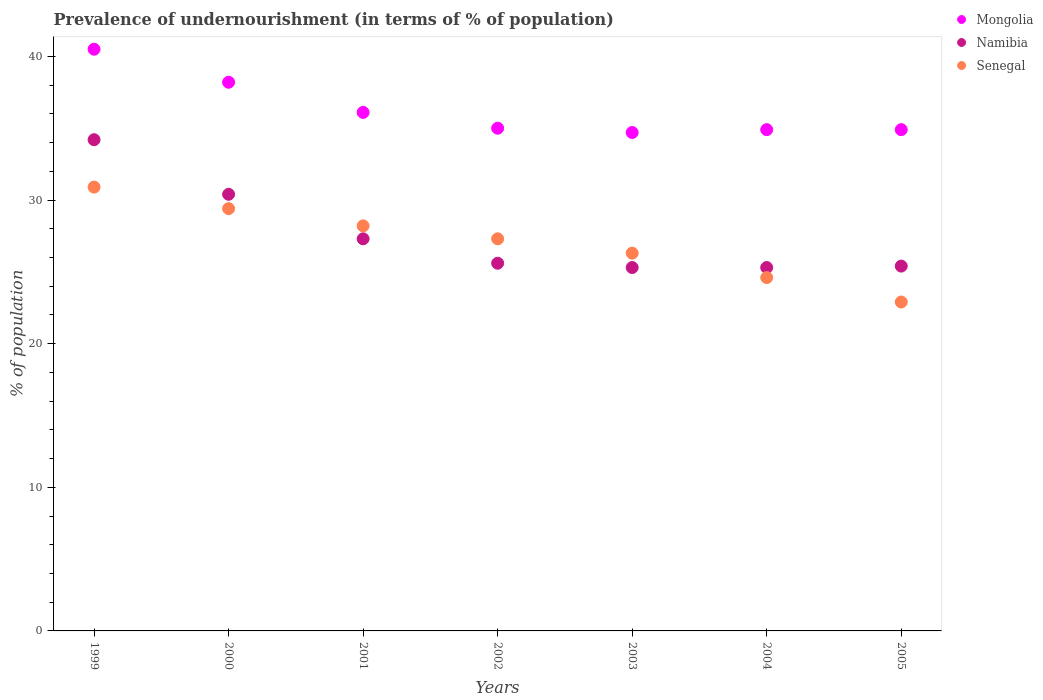How many different coloured dotlines are there?
Ensure brevity in your answer.  3. Is the number of dotlines equal to the number of legend labels?
Give a very brief answer. Yes. What is the percentage of undernourished population in Mongolia in 2004?
Your answer should be very brief. 34.9. Across all years, what is the maximum percentage of undernourished population in Senegal?
Your response must be concise. 30.9. Across all years, what is the minimum percentage of undernourished population in Senegal?
Make the answer very short. 22.9. In which year was the percentage of undernourished population in Senegal maximum?
Your response must be concise. 1999. What is the total percentage of undernourished population in Namibia in the graph?
Provide a succinct answer. 193.5. What is the difference between the percentage of undernourished population in Mongolia in 1999 and that in 2000?
Provide a short and direct response. 2.3. What is the difference between the percentage of undernourished population in Senegal in 2004 and the percentage of undernourished population in Mongolia in 2003?
Offer a terse response. -10.1. What is the average percentage of undernourished population in Senegal per year?
Offer a very short reply. 27.09. What is the ratio of the percentage of undernourished population in Senegal in 2004 to that in 2005?
Your answer should be very brief. 1.07. Is the percentage of undernourished population in Senegal in 2003 less than that in 2005?
Offer a very short reply. No. Is the difference between the percentage of undernourished population in Namibia in 2000 and 2001 greater than the difference between the percentage of undernourished population in Senegal in 2000 and 2001?
Your response must be concise. Yes. What is the difference between the highest and the second highest percentage of undernourished population in Senegal?
Your response must be concise. 1.5. What is the difference between the highest and the lowest percentage of undernourished population in Namibia?
Offer a very short reply. 8.9. In how many years, is the percentage of undernourished population in Namibia greater than the average percentage of undernourished population in Namibia taken over all years?
Your answer should be compact. 2. Is it the case that in every year, the sum of the percentage of undernourished population in Senegal and percentage of undernourished population in Namibia  is greater than the percentage of undernourished population in Mongolia?
Keep it short and to the point. Yes. Is the percentage of undernourished population in Namibia strictly less than the percentage of undernourished population in Mongolia over the years?
Your response must be concise. Yes. How many dotlines are there?
Ensure brevity in your answer.  3. How many years are there in the graph?
Provide a succinct answer. 7. What is the difference between two consecutive major ticks on the Y-axis?
Offer a terse response. 10. Does the graph contain any zero values?
Make the answer very short. No. Where does the legend appear in the graph?
Your response must be concise. Top right. How many legend labels are there?
Provide a succinct answer. 3. What is the title of the graph?
Offer a terse response. Prevalence of undernourishment (in terms of % of population). What is the label or title of the Y-axis?
Provide a succinct answer. % of population. What is the % of population of Mongolia in 1999?
Offer a very short reply. 40.5. What is the % of population in Namibia in 1999?
Provide a short and direct response. 34.2. What is the % of population in Senegal in 1999?
Your response must be concise. 30.9. What is the % of population of Mongolia in 2000?
Ensure brevity in your answer.  38.2. What is the % of population in Namibia in 2000?
Ensure brevity in your answer.  30.4. What is the % of population in Senegal in 2000?
Offer a very short reply. 29.4. What is the % of population in Mongolia in 2001?
Give a very brief answer. 36.1. What is the % of population in Namibia in 2001?
Provide a succinct answer. 27.3. What is the % of population in Senegal in 2001?
Offer a very short reply. 28.2. What is the % of population in Mongolia in 2002?
Give a very brief answer. 35. What is the % of population of Namibia in 2002?
Offer a terse response. 25.6. What is the % of population in Senegal in 2002?
Offer a terse response. 27.3. What is the % of population of Mongolia in 2003?
Make the answer very short. 34.7. What is the % of population of Namibia in 2003?
Your answer should be compact. 25.3. What is the % of population of Senegal in 2003?
Make the answer very short. 26.3. What is the % of population in Mongolia in 2004?
Ensure brevity in your answer.  34.9. What is the % of population of Namibia in 2004?
Offer a very short reply. 25.3. What is the % of population in Senegal in 2004?
Offer a very short reply. 24.6. What is the % of population in Mongolia in 2005?
Provide a succinct answer. 34.9. What is the % of population in Namibia in 2005?
Offer a very short reply. 25.4. What is the % of population of Senegal in 2005?
Your answer should be compact. 22.9. Across all years, what is the maximum % of population of Mongolia?
Provide a short and direct response. 40.5. Across all years, what is the maximum % of population of Namibia?
Keep it short and to the point. 34.2. Across all years, what is the maximum % of population of Senegal?
Make the answer very short. 30.9. Across all years, what is the minimum % of population of Mongolia?
Provide a short and direct response. 34.7. Across all years, what is the minimum % of population of Namibia?
Offer a terse response. 25.3. Across all years, what is the minimum % of population in Senegal?
Provide a succinct answer. 22.9. What is the total % of population in Mongolia in the graph?
Provide a short and direct response. 254.3. What is the total % of population in Namibia in the graph?
Offer a very short reply. 193.5. What is the total % of population of Senegal in the graph?
Your answer should be compact. 189.6. What is the difference between the % of population in Mongolia in 1999 and that in 2000?
Provide a succinct answer. 2.3. What is the difference between the % of population of Senegal in 1999 and that in 2000?
Ensure brevity in your answer.  1.5. What is the difference between the % of population in Mongolia in 1999 and that in 2001?
Keep it short and to the point. 4.4. What is the difference between the % of population of Namibia in 1999 and that in 2001?
Your answer should be compact. 6.9. What is the difference between the % of population of Mongolia in 1999 and that in 2002?
Keep it short and to the point. 5.5. What is the difference between the % of population in Senegal in 1999 and that in 2002?
Keep it short and to the point. 3.6. What is the difference between the % of population of Namibia in 1999 and that in 2003?
Your response must be concise. 8.9. What is the difference between the % of population of Senegal in 1999 and that in 2003?
Make the answer very short. 4.6. What is the difference between the % of population of Namibia in 1999 and that in 2004?
Ensure brevity in your answer.  8.9. What is the difference between the % of population in Senegal in 1999 and that in 2004?
Keep it short and to the point. 6.3. What is the difference between the % of population in Mongolia in 1999 and that in 2005?
Make the answer very short. 5.6. What is the difference between the % of population in Namibia in 1999 and that in 2005?
Make the answer very short. 8.8. What is the difference between the % of population in Senegal in 1999 and that in 2005?
Ensure brevity in your answer.  8. What is the difference between the % of population of Mongolia in 2000 and that in 2001?
Provide a succinct answer. 2.1. What is the difference between the % of population of Senegal in 2000 and that in 2001?
Make the answer very short. 1.2. What is the difference between the % of population in Namibia in 2000 and that in 2002?
Ensure brevity in your answer.  4.8. What is the difference between the % of population of Mongolia in 2000 and that in 2003?
Provide a succinct answer. 3.5. What is the difference between the % of population of Namibia in 2000 and that in 2003?
Offer a very short reply. 5.1. What is the difference between the % of population of Mongolia in 2000 and that in 2004?
Offer a very short reply. 3.3. What is the difference between the % of population of Senegal in 2000 and that in 2004?
Make the answer very short. 4.8. What is the difference between the % of population of Senegal in 2000 and that in 2005?
Ensure brevity in your answer.  6.5. What is the difference between the % of population of Mongolia in 2001 and that in 2002?
Provide a succinct answer. 1.1. What is the difference between the % of population of Senegal in 2001 and that in 2002?
Make the answer very short. 0.9. What is the difference between the % of population of Mongolia in 2001 and that in 2003?
Keep it short and to the point. 1.4. What is the difference between the % of population in Senegal in 2001 and that in 2003?
Give a very brief answer. 1.9. What is the difference between the % of population of Namibia in 2001 and that in 2005?
Provide a succinct answer. 1.9. What is the difference between the % of population in Senegal in 2001 and that in 2005?
Keep it short and to the point. 5.3. What is the difference between the % of population in Mongolia in 2002 and that in 2004?
Offer a very short reply. 0.1. What is the difference between the % of population in Namibia in 2002 and that in 2004?
Give a very brief answer. 0.3. What is the difference between the % of population of Senegal in 2002 and that in 2004?
Your response must be concise. 2.7. What is the difference between the % of population in Mongolia in 2003 and that in 2005?
Your answer should be compact. -0.2. What is the difference between the % of population of Mongolia in 2004 and that in 2005?
Offer a very short reply. 0. What is the difference between the % of population in Namibia in 2004 and that in 2005?
Provide a succinct answer. -0.1. What is the difference between the % of population of Mongolia in 1999 and the % of population of Namibia in 2000?
Your answer should be very brief. 10.1. What is the difference between the % of population in Mongolia in 1999 and the % of population in Senegal in 2000?
Provide a short and direct response. 11.1. What is the difference between the % of population of Namibia in 1999 and the % of population of Senegal in 2000?
Keep it short and to the point. 4.8. What is the difference between the % of population of Mongolia in 1999 and the % of population of Senegal in 2001?
Your answer should be very brief. 12.3. What is the difference between the % of population of Namibia in 1999 and the % of population of Senegal in 2001?
Provide a succinct answer. 6. What is the difference between the % of population in Mongolia in 1999 and the % of population in Senegal in 2002?
Provide a short and direct response. 13.2. What is the difference between the % of population in Mongolia in 1999 and the % of population in Namibia in 2003?
Your response must be concise. 15.2. What is the difference between the % of population in Mongolia in 1999 and the % of population in Senegal in 2003?
Your response must be concise. 14.2. What is the difference between the % of population of Namibia in 1999 and the % of population of Senegal in 2003?
Make the answer very short. 7.9. What is the difference between the % of population of Mongolia in 1999 and the % of population of Namibia in 2004?
Your answer should be compact. 15.2. What is the difference between the % of population of Mongolia in 1999 and the % of population of Namibia in 2005?
Your answer should be compact. 15.1. What is the difference between the % of population of Namibia in 1999 and the % of population of Senegal in 2005?
Give a very brief answer. 11.3. What is the difference between the % of population in Mongolia in 2000 and the % of population in Namibia in 2001?
Make the answer very short. 10.9. What is the difference between the % of population in Mongolia in 2000 and the % of population in Senegal in 2001?
Your response must be concise. 10. What is the difference between the % of population of Mongolia in 2000 and the % of population of Senegal in 2002?
Your answer should be very brief. 10.9. What is the difference between the % of population of Mongolia in 2000 and the % of population of Senegal in 2003?
Offer a very short reply. 11.9. What is the difference between the % of population of Namibia in 2000 and the % of population of Senegal in 2003?
Provide a succinct answer. 4.1. What is the difference between the % of population of Mongolia in 2000 and the % of population of Senegal in 2004?
Make the answer very short. 13.6. What is the difference between the % of population of Namibia in 2000 and the % of population of Senegal in 2004?
Provide a short and direct response. 5.8. What is the difference between the % of population in Mongolia in 2000 and the % of population in Senegal in 2005?
Provide a short and direct response. 15.3. What is the difference between the % of population of Namibia in 2000 and the % of population of Senegal in 2005?
Provide a succinct answer. 7.5. What is the difference between the % of population of Mongolia in 2001 and the % of population of Namibia in 2002?
Make the answer very short. 10.5. What is the difference between the % of population in Mongolia in 2001 and the % of population in Senegal in 2002?
Offer a terse response. 8.8. What is the difference between the % of population of Namibia in 2001 and the % of population of Senegal in 2002?
Your response must be concise. 0. What is the difference between the % of population of Mongolia in 2001 and the % of population of Senegal in 2003?
Ensure brevity in your answer.  9.8. What is the difference between the % of population of Mongolia in 2001 and the % of population of Namibia in 2005?
Provide a short and direct response. 10.7. What is the difference between the % of population of Mongolia in 2001 and the % of population of Senegal in 2005?
Your response must be concise. 13.2. What is the difference between the % of population in Namibia in 2001 and the % of population in Senegal in 2005?
Your response must be concise. 4.4. What is the difference between the % of population of Mongolia in 2002 and the % of population of Senegal in 2003?
Provide a succinct answer. 8.7. What is the difference between the % of population of Mongolia in 2002 and the % of population of Namibia in 2004?
Your answer should be very brief. 9.7. What is the difference between the % of population in Mongolia in 2002 and the % of population in Senegal in 2004?
Keep it short and to the point. 10.4. What is the difference between the % of population of Mongolia in 2003 and the % of population of Namibia in 2004?
Keep it short and to the point. 9.4. What is the difference between the % of population of Mongolia in 2003 and the % of population of Senegal in 2004?
Provide a succinct answer. 10.1. What is the difference between the % of population of Namibia in 2004 and the % of population of Senegal in 2005?
Your response must be concise. 2.4. What is the average % of population of Mongolia per year?
Make the answer very short. 36.33. What is the average % of population in Namibia per year?
Your response must be concise. 27.64. What is the average % of population of Senegal per year?
Offer a terse response. 27.09. In the year 1999, what is the difference between the % of population in Mongolia and % of population in Namibia?
Provide a succinct answer. 6.3. In the year 2000, what is the difference between the % of population of Mongolia and % of population of Senegal?
Ensure brevity in your answer.  8.8. In the year 2001, what is the difference between the % of population in Mongolia and % of population in Namibia?
Provide a succinct answer. 8.8. In the year 2001, what is the difference between the % of population of Mongolia and % of population of Senegal?
Your answer should be compact. 7.9. In the year 2003, what is the difference between the % of population of Mongolia and % of population of Senegal?
Your answer should be very brief. 8.4. In the year 2003, what is the difference between the % of population of Namibia and % of population of Senegal?
Provide a short and direct response. -1. In the year 2004, what is the difference between the % of population of Namibia and % of population of Senegal?
Offer a very short reply. 0.7. What is the ratio of the % of population of Mongolia in 1999 to that in 2000?
Make the answer very short. 1.06. What is the ratio of the % of population in Senegal in 1999 to that in 2000?
Give a very brief answer. 1.05. What is the ratio of the % of population in Mongolia in 1999 to that in 2001?
Provide a short and direct response. 1.12. What is the ratio of the % of population in Namibia in 1999 to that in 2001?
Offer a very short reply. 1.25. What is the ratio of the % of population in Senegal in 1999 to that in 2001?
Your answer should be very brief. 1.1. What is the ratio of the % of population in Mongolia in 1999 to that in 2002?
Provide a short and direct response. 1.16. What is the ratio of the % of population of Namibia in 1999 to that in 2002?
Make the answer very short. 1.34. What is the ratio of the % of population of Senegal in 1999 to that in 2002?
Keep it short and to the point. 1.13. What is the ratio of the % of population of Mongolia in 1999 to that in 2003?
Your response must be concise. 1.17. What is the ratio of the % of population in Namibia in 1999 to that in 2003?
Your answer should be compact. 1.35. What is the ratio of the % of population in Senegal in 1999 to that in 2003?
Your response must be concise. 1.17. What is the ratio of the % of population in Mongolia in 1999 to that in 2004?
Provide a succinct answer. 1.16. What is the ratio of the % of population in Namibia in 1999 to that in 2004?
Offer a very short reply. 1.35. What is the ratio of the % of population of Senegal in 1999 to that in 2004?
Offer a terse response. 1.26. What is the ratio of the % of population in Mongolia in 1999 to that in 2005?
Provide a short and direct response. 1.16. What is the ratio of the % of population of Namibia in 1999 to that in 2005?
Give a very brief answer. 1.35. What is the ratio of the % of population in Senegal in 1999 to that in 2005?
Offer a very short reply. 1.35. What is the ratio of the % of population in Mongolia in 2000 to that in 2001?
Make the answer very short. 1.06. What is the ratio of the % of population of Namibia in 2000 to that in 2001?
Offer a very short reply. 1.11. What is the ratio of the % of population in Senegal in 2000 to that in 2001?
Ensure brevity in your answer.  1.04. What is the ratio of the % of population in Mongolia in 2000 to that in 2002?
Provide a succinct answer. 1.09. What is the ratio of the % of population of Namibia in 2000 to that in 2002?
Your answer should be compact. 1.19. What is the ratio of the % of population in Senegal in 2000 to that in 2002?
Make the answer very short. 1.08. What is the ratio of the % of population in Mongolia in 2000 to that in 2003?
Keep it short and to the point. 1.1. What is the ratio of the % of population in Namibia in 2000 to that in 2003?
Ensure brevity in your answer.  1.2. What is the ratio of the % of population in Senegal in 2000 to that in 2003?
Make the answer very short. 1.12. What is the ratio of the % of population of Mongolia in 2000 to that in 2004?
Provide a succinct answer. 1.09. What is the ratio of the % of population of Namibia in 2000 to that in 2004?
Offer a very short reply. 1.2. What is the ratio of the % of population of Senegal in 2000 to that in 2004?
Your answer should be very brief. 1.2. What is the ratio of the % of population in Mongolia in 2000 to that in 2005?
Provide a short and direct response. 1.09. What is the ratio of the % of population of Namibia in 2000 to that in 2005?
Make the answer very short. 1.2. What is the ratio of the % of population of Senegal in 2000 to that in 2005?
Your answer should be compact. 1.28. What is the ratio of the % of population in Mongolia in 2001 to that in 2002?
Your answer should be very brief. 1.03. What is the ratio of the % of population of Namibia in 2001 to that in 2002?
Make the answer very short. 1.07. What is the ratio of the % of population of Senegal in 2001 to that in 2002?
Offer a very short reply. 1.03. What is the ratio of the % of population of Mongolia in 2001 to that in 2003?
Provide a succinct answer. 1.04. What is the ratio of the % of population of Namibia in 2001 to that in 2003?
Your answer should be compact. 1.08. What is the ratio of the % of population of Senegal in 2001 to that in 2003?
Give a very brief answer. 1.07. What is the ratio of the % of population in Mongolia in 2001 to that in 2004?
Offer a very short reply. 1.03. What is the ratio of the % of population in Namibia in 2001 to that in 2004?
Your response must be concise. 1.08. What is the ratio of the % of population in Senegal in 2001 to that in 2004?
Give a very brief answer. 1.15. What is the ratio of the % of population of Mongolia in 2001 to that in 2005?
Offer a terse response. 1.03. What is the ratio of the % of population in Namibia in 2001 to that in 2005?
Your answer should be compact. 1.07. What is the ratio of the % of population of Senegal in 2001 to that in 2005?
Provide a succinct answer. 1.23. What is the ratio of the % of population of Mongolia in 2002 to that in 2003?
Ensure brevity in your answer.  1.01. What is the ratio of the % of population in Namibia in 2002 to that in 2003?
Keep it short and to the point. 1.01. What is the ratio of the % of population in Senegal in 2002 to that in 2003?
Your response must be concise. 1.04. What is the ratio of the % of population of Mongolia in 2002 to that in 2004?
Your answer should be very brief. 1. What is the ratio of the % of population in Namibia in 2002 to that in 2004?
Your response must be concise. 1.01. What is the ratio of the % of population in Senegal in 2002 to that in 2004?
Offer a terse response. 1.11. What is the ratio of the % of population in Namibia in 2002 to that in 2005?
Your answer should be compact. 1.01. What is the ratio of the % of population in Senegal in 2002 to that in 2005?
Offer a terse response. 1.19. What is the ratio of the % of population of Senegal in 2003 to that in 2004?
Give a very brief answer. 1.07. What is the ratio of the % of population in Senegal in 2003 to that in 2005?
Your answer should be compact. 1.15. What is the ratio of the % of population of Mongolia in 2004 to that in 2005?
Offer a terse response. 1. What is the ratio of the % of population of Namibia in 2004 to that in 2005?
Give a very brief answer. 1. What is the ratio of the % of population in Senegal in 2004 to that in 2005?
Your answer should be compact. 1.07. What is the difference between the highest and the second highest % of population in Mongolia?
Your answer should be very brief. 2.3. What is the difference between the highest and the second highest % of population of Namibia?
Offer a very short reply. 3.8. What is the difference between the highest and the second highest % of population of Senegal?
Your answer should be compact. 1.5. What is the difference between the highest and the lowest % of population of Mongolia?
Provide a succinct answer. 5.8. What is the difference between the highest and the lowest % of population in Senegal?
Your answer should be compact. 8. 